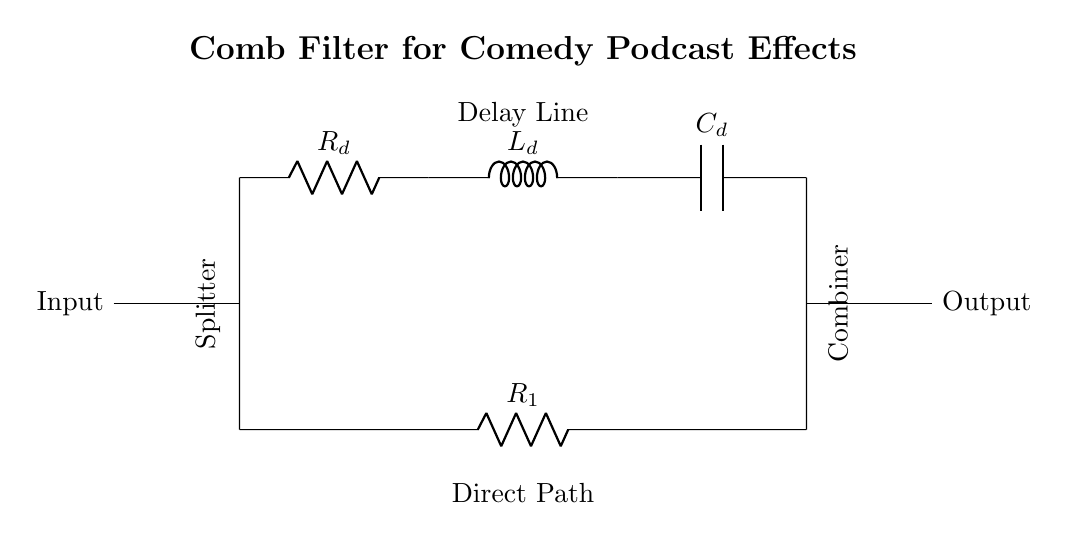What is the primary function of this circuit? The primary function of this circuit is to create unique sound effects through a comb filter, which utilizes delayed signals to form constructive and destructive interference, allowing for different auditory experiences.
Answer: Comb filter What components are used in the delay line? The delay line consists of a resistor, an inductor, and a capacitor, which work together to create a time delay for the input signal, thereby shaping the output sound.
Answer: Resistor, inductor, capacitor How many paths does the input signal take in this circuit? The input signal takes two paths: one travels directly through the resistor labeled R1, while the other follows the delay line before being recombined. The splitter ensures both paths are utilized, which is characteristic of a comb filter.
Answer: Two paths What is the role of the combiner in this circuit? The combiner's role is to merge the output from the delay line and the direct path, allowing for the combined effects of both signals. This is essential in creating the unique sound properties of the comb filter.
Answer: Merge output signals What is the effect of the component values R_d, L_d, and C_d? The values of R_d, L_d, and C_d determine the frequency response and time delay characteristics of the comb filter. By altering these values, you can change how the audio sounds, allowing you to create various effects tailored for comedy podcasts or radio shows.
Answer: Determine frequency response What type of filter is illustrated in this circuit? This circuit illustrates a comb filter, which is specifically designed for sound processing by manipulating multiple frequencies through delay and constructive/destructive interference.
Answer: Comb filter How does delaying the signal affect the output? Delaying the signal allows for phase shifts that lead to constructive and destructive interference, resulting in distinct audio effects. As certain frequencies are reinforced while others are canceled out, the overall sound is creatively altered, which is particularly useful in comedic audio contexts.
Answer: Phase shifts create unique effects 